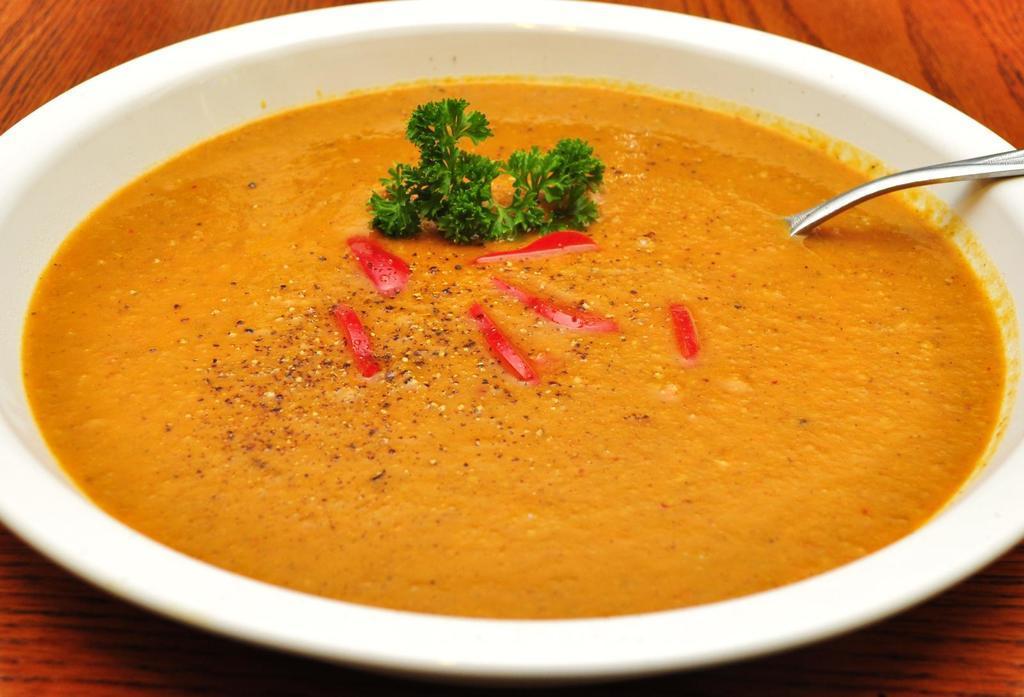In one or two sentences, can you explain what this image depicts? In this image I can see the bowl with food. I can see the bowl is in white color. The food is in red, yellow and green color. I can also see the spoon inside the bowl. It is on the brown color surface. 